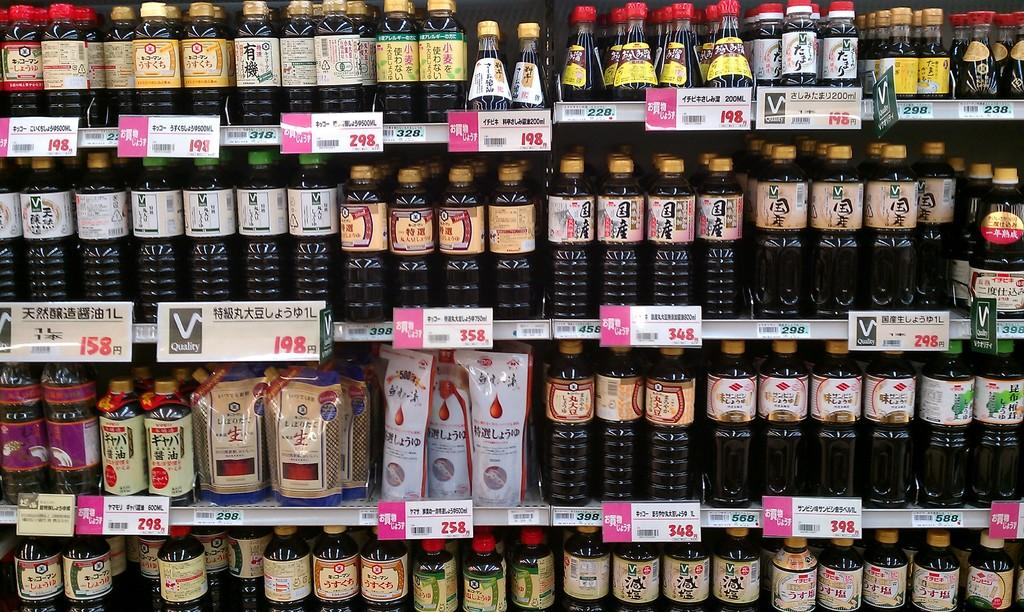<image>
Give a short and clear explanation of the subsequent image. Shelving in a grocery store with various bottles and food products in bags with the price underneath the products in a foreign language. 